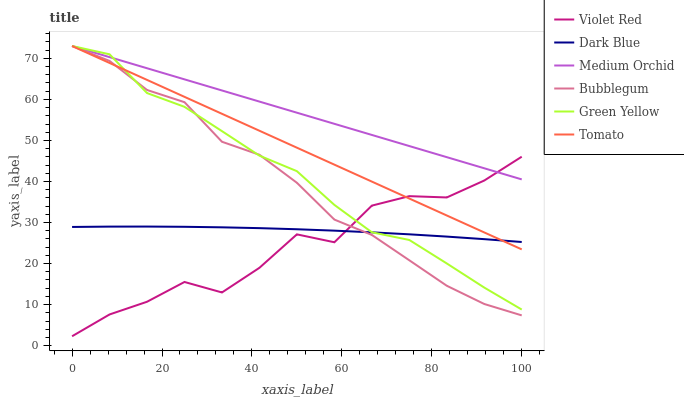Does Violet Red have the minimum area under the curve?
Answer yes or no. Yes. Does Medium Orchid have the maximum area under the curve?
Answer yes or no. Yes. Does Medium Orchid have the minimum area under the curve?
Answer yes or no. No. Does Violet Red have the maximum area under the curve?
Answer yes or no. No. Is Medium Orchid the smoothest?
Answer yes or no. Yes. Is Violet Red the roughest?
Answer yes or no. Yes. Is Violet Red the smoothest?
Answer yes or no. No. Is Medium Orchid the roughest?
Answer yes or no. No. Does Violet Red have the lowest value?
Answer yes or no. Yes. Does Medium Orchid have the lowest value?
Answer yes or no. No. Does Green Yellow have the highest value?
Answer yes or no. Yes. Does Violet Red have the highest value?
Answer yes or no. No. Is Dark Blue less than Medium Orchid?
Answer yes or no. Yes. Is Medium Orchid greater than Dark Blue?
Answer yes or no. Yes. Does Violet Red intersect Green Yellow?
Answer yes or no. Yes. Is Violet Red less than Green Yellow?
Answer yes or no. No. Is Violet Red greater than Green Yellow?
Answer yes or no. No. Does Dark Blue intersect Medium Orchid?
Answer yes or no. No. 